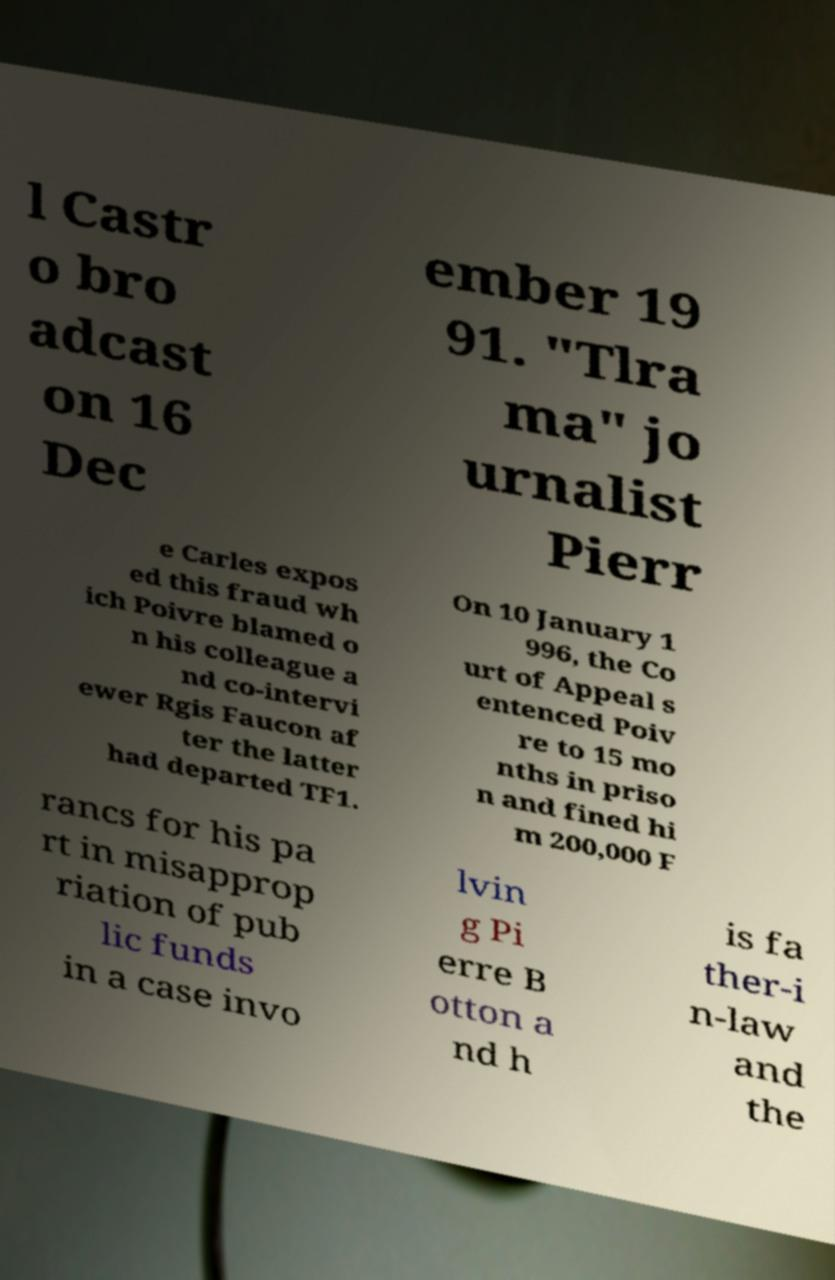For documentation purposes, I need the text within this image transcribed. Could you provide that? l Castr o bro adcast on 16 Dec ember 19 91. "Tlra ma" jo urnalist Pierr e Carles expos ed this fraud wh ich Poivre blamed o n his colleague a nd co-intervi ewer Rgis Faucon af ter the latter had departed TF1. On 10 January 1 996, the Co urt of Appeal s entenced Poiv re to 15 mo nths in priso n and fined hi m 200,000 F rancs for his pa rt in misapprop riation of pub lic funds in a case invo lvin g Pi erre B otton a nd h is fa ther-i n-law and the 